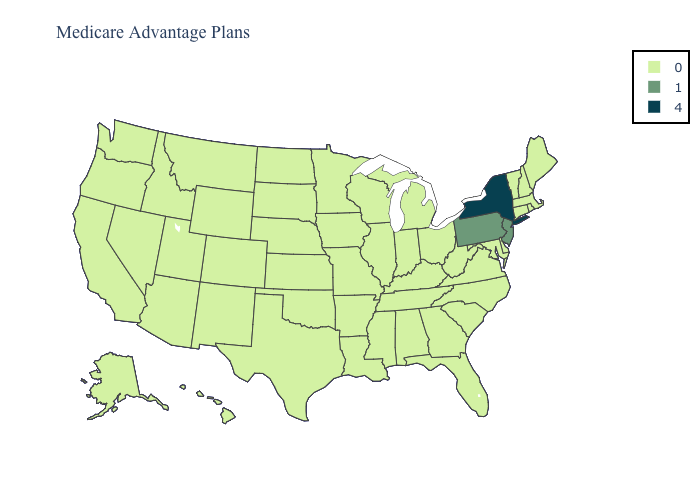What is the value of Utah?
Give a very brief answer. 0. What is the lowest value in the USA?
Write a very short answer. 0. What is the lowest value in the South?
Write a very short answer. 0. Name the states that have a value in the range 4?
Short answer required. New York. What is the value of Arkansas?
Concise answer only. 0. Does New York have the lowest value in the USA?
Be succinct. No. What is the lowest value in the South?
Give a very brief answer. 0. What is the highest value in the USA?
Quick response, please. 4. What is the highest value in the USA?
Answer briefly. 4. Name the states that have a value in the range 0?
Give a very brief answer. Alaska, Alabama, Arkansas, Arizona, California, Colorado, Connecticut, Delaware, Florida, Georgia, Hawaii, Iowa, Idaho, Illinois, Indiana, Kansas, Kentucky, Louisiana, Massachusetts, Maryland, Maine, Michigan, Minnesota, Missouri, Mississippi, Montana, North Carolina, North Dakota, Nebraska, New Hampshire, New Mexico, Nevada, Ohio, Oklahoma, Oregon, Rhode Island, South Carolina, South Dakota, Tennessee, Texas, Utah, Virginia, Vermont, Washington, Wisconsin, West Virginia, Wyoming. What is the lowest value in the Northeast?
Concise answer only. 0. Name the states that have a value in the range 1?
Be succinct. New Jersey, Pennsylvania. Name the states that have a value in the range 0?
Short answer required. Alaska, Alabama, Arkansas, Arizona, California, Colorado, Connecticut, Delaware, Florida, Georgia, Hawaii, Iowa, Idaho, Illinois, Indiana, Kansas, Kentucky, Louisiana, Massachusetts, Maryland, Maine, Michigan, Minnesota, Missouri, Mississippi, Montana, North Carolina, North Dakota, Nebraska, New Hampshire, New Mexico, Nevada, Ohio, Oklahoma, Oregon, Rhode Island, South Carolina, South Dakota, Tennessee, Texas, Utah, Virginia, Vermont, Washington, Wisconsin, West Virginia, Wyoming. Among the states that border Mississippi , which have the lowest value?
Keep it brief. Alabama, Arkansas, Louisiana, Tennessee. 